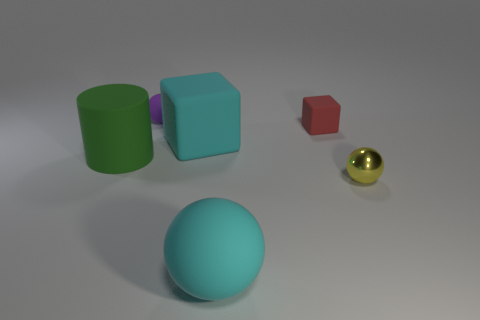Add 2 big balls. How many objects exist? 8 Subtract all cylinders. How many objects are left? 5 Add 1 big red things. How many big red things exist? 1 Subtract 0 green blocks. How many objects are left? 6 Subtract all tiny blocks. Subtract all yellow metal objects. How many objects are left? 4 Add 2 metal things. How many metal things are left? 3 